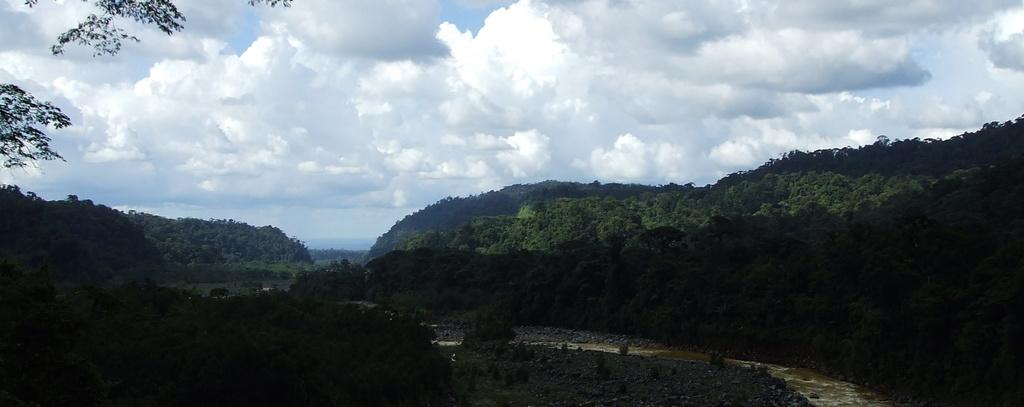What is the main subject of the image? The main subject of the image is a mountain. What can be seen on the mountain? There are trees on the mountain. What is visible at the top of the mountain? The sky is visible at the top of the mountain. What is the condition of the sky in the image? Clouds are present in the sky. What is visible at the bottom of the mountain? There is water visible at the bottom of the mountain. What type of drug is being used for learning purposes in the image? There is no drug or learning activity present in the image; it depicts a mountain with trees, sky, clouds, and water. 